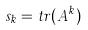Convert formula to latex. <formula><loc_0><loc_0><loc_500><loc_500>s _ { k } = t r ( A ^ { k } )</formula> 